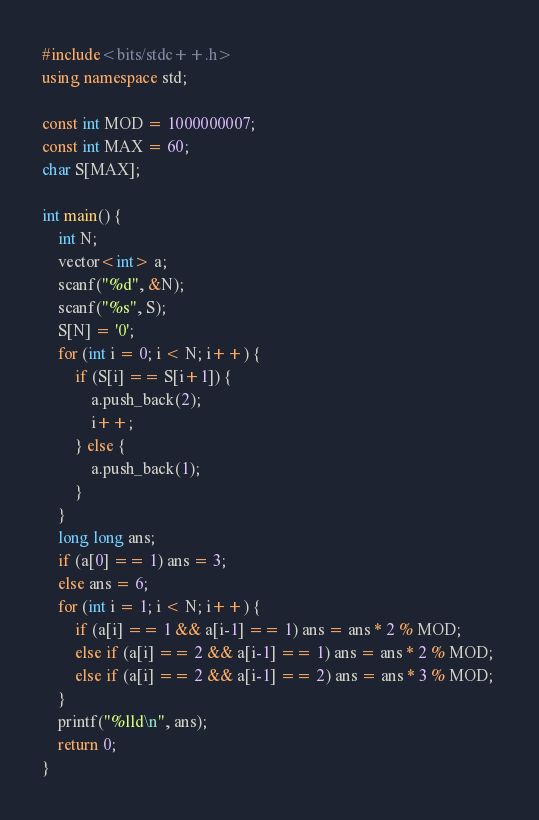Convert code to text. <code><loc_0><loc_0><loc_500><loc_500><_C++_>#include<bits/stdc++.h>
using namespace std;

const int MOD = 1000000007;
const int MAX = 60;
char S[MAX];

int main() {
    int N;
    vector<int> a;
    scanf("%d", &N);
    scanf("%s", S);
    S[N] = '0';
    for (int i = 0; i < N; i++) {
        if (S[i] == S[i+1]) {
            a.push_back(2);
            i++;
        } else {
            a.push_back(1);
        }
    }
    long long ans;
    if (a[0] == 1) ans = 3;
    else ans = 6;
    for (int i = 1; i < N; i++) {
        if (a[i] == 1 && a[i-1] == 1) ans = ans * 2 % MOD;
        else if (a[i] == 2 && a[i-1] == 1) ans = ans * 2 % MOD;
        else if (a[i] == 2 && a[i-1] == 2) ans = ans * 3 % MOD; 
    }
    printf("%lld\n", ans);
    return 0;
}</code> 